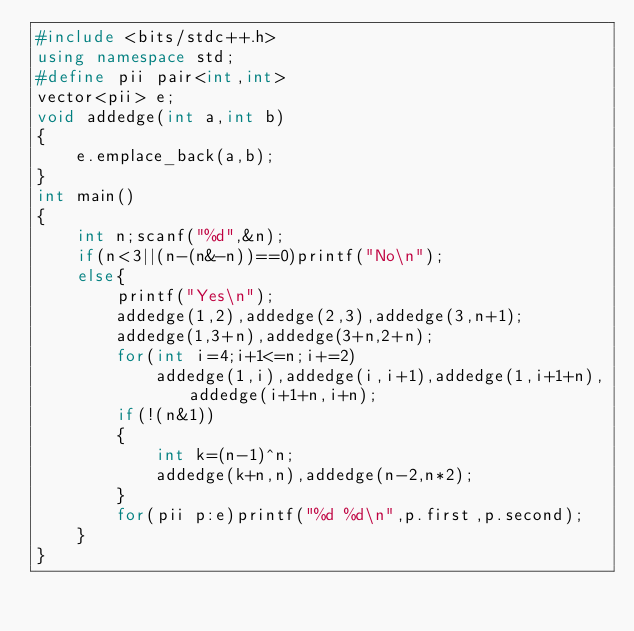<code> <loc_0><loc_0><loc_500><loc_500><_C++_>#include <bits/stdc++.h>
using namespace std;
#define pii pair<int,int>
vector<pii> e;
void addedge(int a,int b)
{
    e.emplace_back(a,b);
}
int main()
{
    int n;scanf("%d",&n);
    if(n<3||(n-(n&-n))==0)printf("No\n");
    else{
        printf("Yes\n");
        addedge(1,2),addedge(2,3),addedge(3,n+1);
        addedge(1,3+n),addedge(3+n,2+n);
        for(int i=4;i+1<=n;i+=2)
            addedge(1,i),addedge(i,i+1),addedge(1,i+1+n),addedge(i+1+n,i+n);
        if(!(n&1))
        {
            int k=(n-1)^n;
            addedge(k+n,n),addedge(n-2,n*2);
        }
        for(pii p:e)printf("%d %d\n",p.first,p.second);
    }
}</code> 